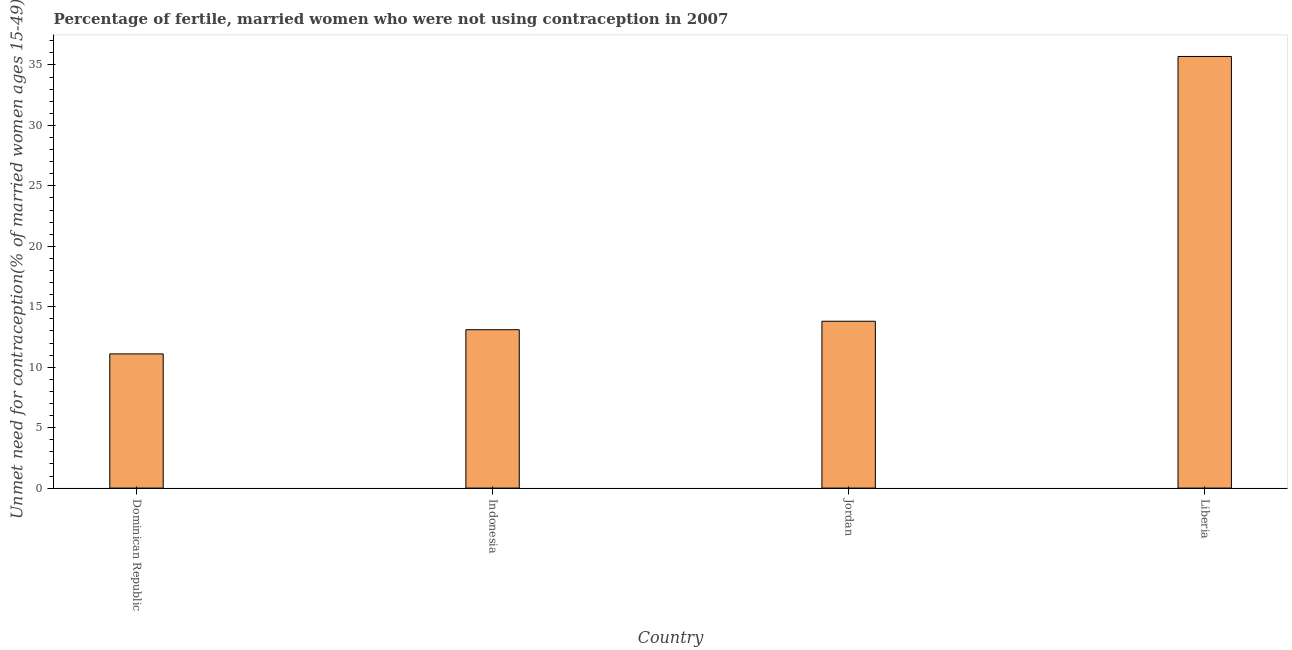Does the graph contain any zero values?
Provide a short and direct response. No. What is the title of the graph?
Give a very brief answer. Percentage of fertile, married women who were not using contraception in 2007. What is the label or title of the Y-axis?
Your answer should be very brief.  Unmet need for contraception(% of married women ages 15-49). Across all countries, what is the maximum number of married women who are not using contraception?
Your answer should be compact. 35.7. Across all countries, what is the minimum number of married women who are not using contraception?
Ensure brevity in your answer.  11.1. In which country was the number of married women who are not using contraception maximum?
Your answer should be very brief. Liberia. In which country was the number of married women who are not using contraception minimum?
Provide a succinct answer. Dominican Republic. What is the sum of the number of married women who are not using contraception?
Offer a terse response. 73.7. What is the difference between the number of married women who are not using contraception in Indonesia and Liberia?
Your answer should be very brief. -22.6. What is the average number of married women who are not using contraception per country?
Provide a short and direct response. 18.43. What is the median number of married women who are not using contraception?
Make the answer very short. 13.45. What is the ratio of the number of married women who are not using contraception in Indonesia to that in Liberia?
Your answer should be very brief. 0.37. Is the difference between the number of married women who are not using contraception in Dominican Republic and Jordan greater than the difference between any two countries?
Provide a succinct answer. No. What is the difference between the highest and the second highest number of married women who are not using contraception?
Your response must be concise. 21.9. Is the sum of the number of married women who are not using contraception in Indonesia and Liberia greater than the maximum number of married women who are not using contraception across all countries?
Keep it short and to the point. Yes. What is the difference between the highest and the lowest number of married women who are not using contraception?
Provide a succinct answer. 24.6. In how many countries, is the number of married women who are not using contraception greater than the average number of married women who are not using contraception taken over all countries?
Make the answer very short. 1. Are all the bars in the graph horizontal?
Keep it short and to the point. No. Are the values on the major ticks of Y-axis written in scientific E-notation?
Your answer should be compact. No. What is the  Unmet need for contraception(% of married women ages 15-49) of Indonesia?
Provide a short and direct response. 13.1. What is the  Unmet need for contraception(% of married women ages 15-49) in Jordan?
Your response must be concise. 13.8. What is the  Unmet need for contraception(% of married women ages 15-49) in Liberia?
Provide a short and direct response. 35.7. What is the difference between the  Unmet need for contraception(% of married women ages 15-49) in Dominican Republic and Liberia?
Provide a succinct answer. -24.6. What is the difference between the  Unmet need for contraception(% of married women ages 15-49) in Indonesia and Jordan?
Offer a very short reply. -0.7. What is the difference between the  Unmet need for contraception(% of married women ages 15-49) in Indonesia and Liberia?
Provide a succinct answer. -22.6. What is the difference between the  Unmet need for contraception(% of married women ages 15-49) in Jordan and Liberia?
Offer a very short reply. -21.9. What is the ratio of the  Unmet need for contraception(% of married women ages 15-49) in Dominican Republic to that in Indonesia?
Offer a terse response. 0.85. What is the ratio of the  Unmet need for contraception(% of married women ages 15-49) in Dominican Republic to that in Jordan?
Your response must be concise. 0.8. What is the ratio of the  Unmet need for contraception(% of married women ages 15-49) in Dominican Republic to that in Liberia?
Provide a short and direct response. 0.31. What is the ratio of the  Unmet need for contraception(% of married women ages 15-49) in Indonesia to that in Jordan?
Keep it short and to the point. 0.95. What is the ratio of the  Unmet need for contraception(% of married women ages 15-49) in Indonesia to that in Liberia?
Your response must be concise. 0.37. What is the ratio of the  Unmet need for contraception(% of married women ages 15-49) in Jordan to that in Liberia?
Ensure brevity in your answer.  0.39. 